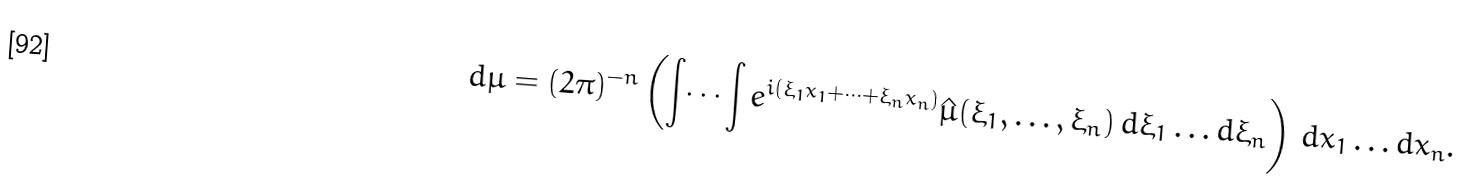<formula> <loc_0><loc_0><loc_500><loc_500>d \mu = ( 2 \pi ) ^ { - n } \left ( \int \dots \int e ^ { i ( \xi _ { 1 } x _ { 1 } + \dots + \xi _ { n } x _ { n } ) } \hat { \mu } ( \xi _ { 1 } , \dots , \xi _ { n } ) \, d \xi _ { 1 } \dots d \xi _ { n } \right ) \, d x _ { 1 } \dots d x _ { n } .</formula> 